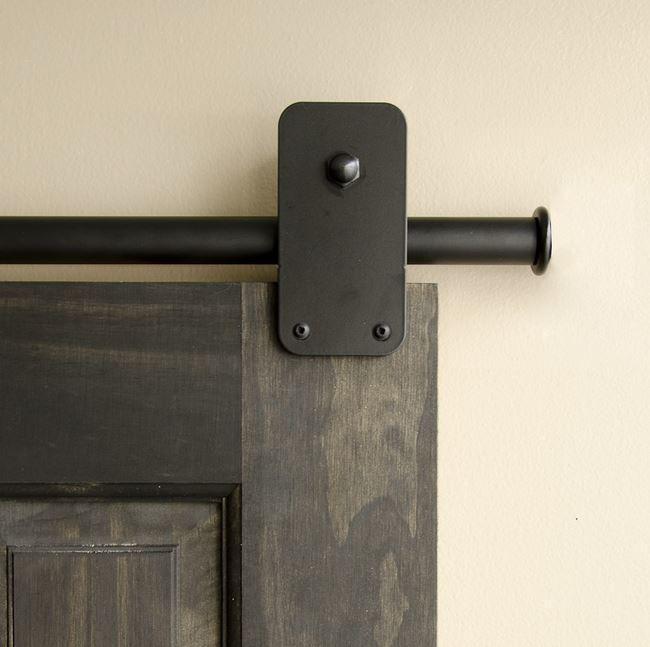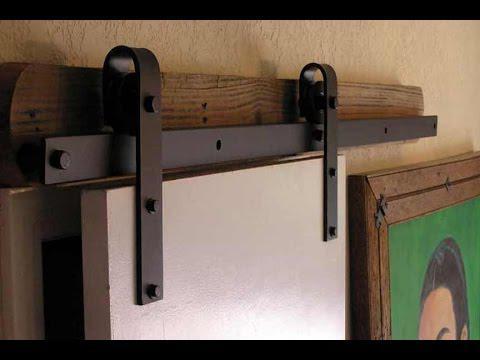The first image is the image on the left, the second image is the image on the right. Considering the images on both sides, is "The door section shown in the left image is not displayed at an angle." valid? Answer yes or no. Yes. 